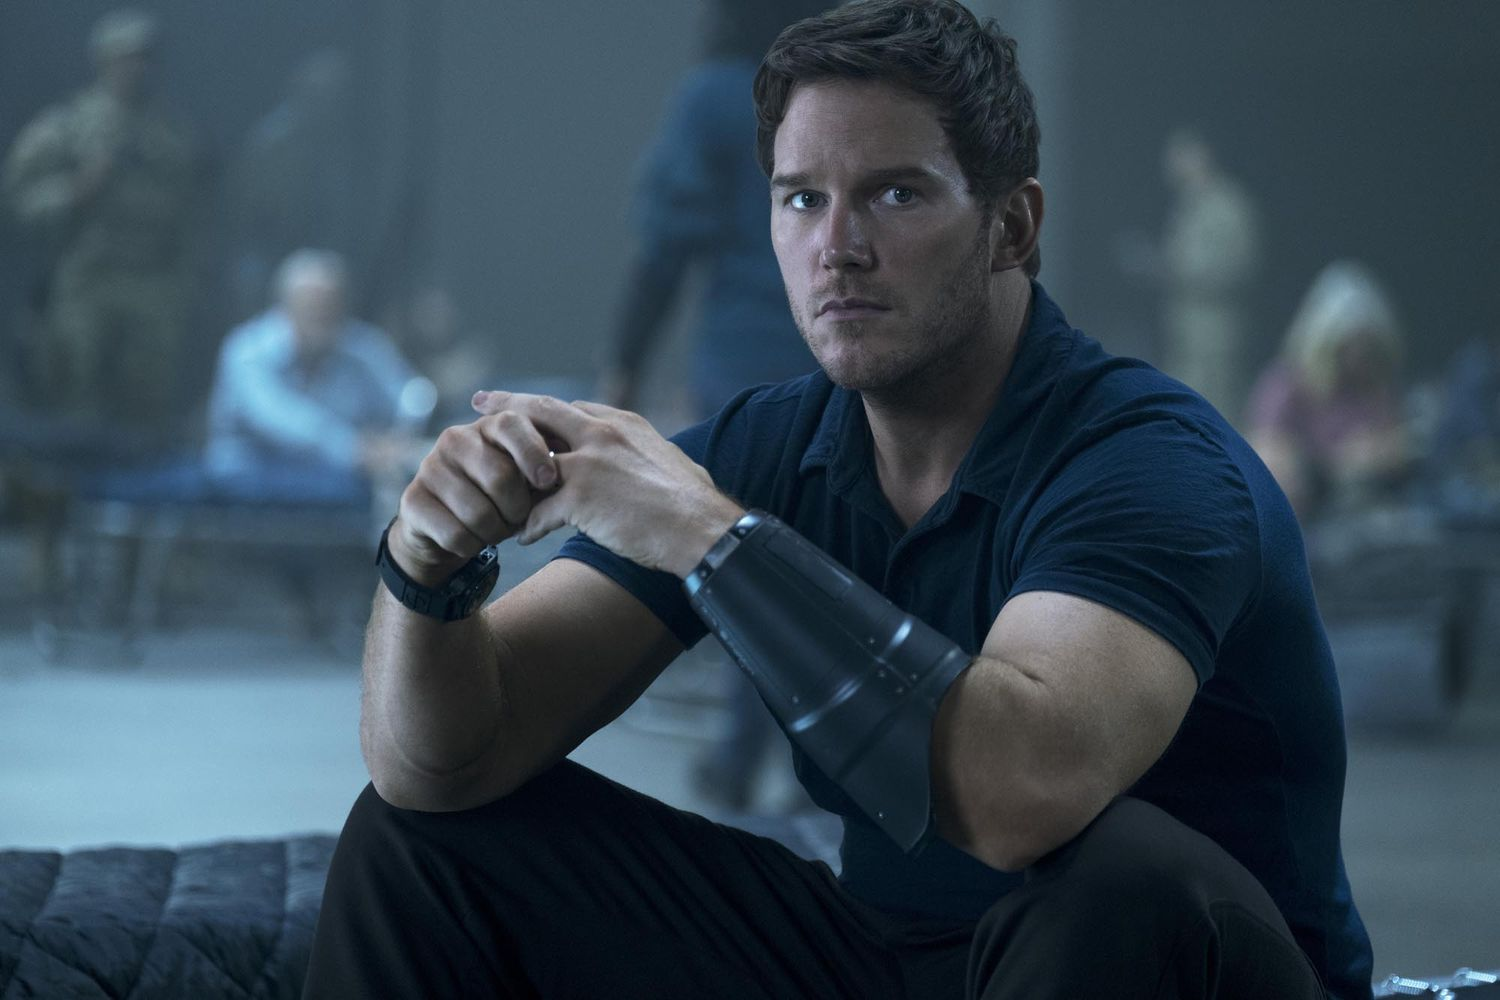How does the setting contribute to the mood of this picture? The setting, with its blurred background and indistinct figures, creates a sense of activity and urgency around the seated individual, emphasizing their solitary and contemplative mood amidst a bustling environment. 